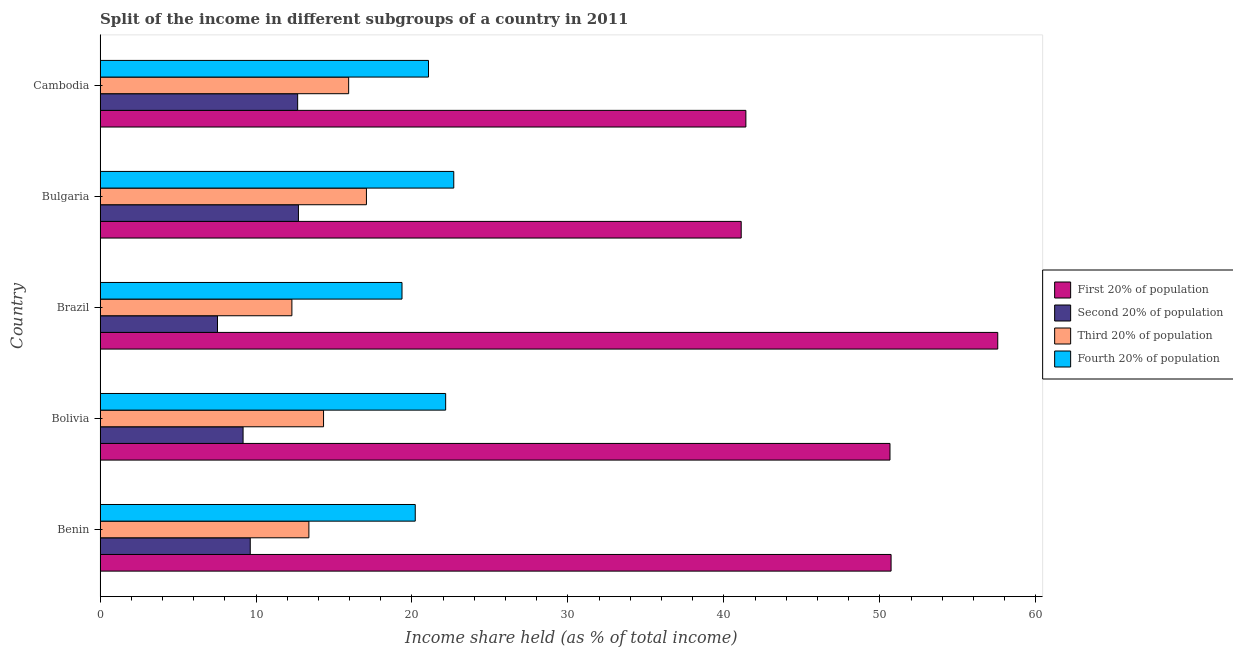Are the number of bars per tick equal to the number of legend labels?
Your response must be concise. Yes. Are the number of bars on each tick of the Y-axis equal?
Your answer should be very brief. Yes. How many bars are there on the 1st tick from the top?
Make the answer very short. 4. How many bars are there on the 4th tick from the bottom?
Offer a terse response. 4. What is the label of the 2nd group of bars from the top?
Your answer should be very brief. Bulgaria. What is the share of the income held by second 20% of the population in Bulgaria?
Provide a short and direct response. 12.72. Across all countries, what is the maximum share of the income held by third 20% of the population?
Provide a succinct answer. 17.08. Across all countries, what is the minimum share of the income held by second 20% of the population?
Provide a short and direct response. 7.53. In which country was the share of the income held by third 20% of the population maximum?
Offer a terse response. Bulgaria. What is the total share of the income held by fourth 20% of the population in the graph?
Give a very brief answer. 105.47. What is the difference between the share of the income held by fourth 20% of the population in Brazil and that in Bulgaria?
Your answer should be compact. -3.32. What is the difference between the share of the income held by third 20% of the population in Benin and the share of the income held by second 20% of the population in Cambodia?
Your answer should be very brief. 0.72. What is the average share of the income held by fourth 20% of the population per country?
Your answer should be compact. 21.09. What is the difference between the share of the income held by fourth 20% of the population and share of the income held by second 20% of the population in Brazil?
Provide a short and direct response. 11.83. In how many countries, is the share of the income held by first 20% of the population greater than 22 %?
Give a very brief answer. 5. What is the ratio of the share of the income held by first 20% of the population in Benin to that in Bulgaria?
Give a very brief answer. 1.23. What is the difference between the highest and the second highest share of the income held by first 20% of the population?
Your answer should be compact. 6.84. What is the difference between the highest and the lowest share of the income held by second 20% of the population?
Keep it short and to the point. 5.19. In how many countries, is the share of the income held by third 20% of the population greater than the average share of the income held by third 20% of the population taken over all countries?
Make the answer very short. 2. What does the 2nd bar from the top in Brazil represents?
Your answer should be very brief. Third 20% of population. What does the 1st bar from the bottom in Cambodia represents?
Keep it short and to the point. First 20% of population. Is it the case that in every country, the sum of the share of the income held by first 20% of the population and share of the income held by second 20% of the population is greater than the share of the income held by third 20% of the population?
Provide a succinct answer. Yes. How many bars are there?
Make the answer very short. 20. Are all the bars in the graph horizontal?
Your answer should be compact. Yes. Does the graph contain grids?
Your answer should be very brief. No. How are the legend labels stacked?
Offer a very short reply. Vertical. What is the title of the graph?
Ensure brevity in your answer.  Split of the income in different subgroups of a country in 2011. Does "Subsidies and Transfers" appear as one of the legend labels in the graph?
Offer a terse response. No. What is the label or title of the X-axis?
Your answer should be compact. Income share held (as % of total income). What is the label or title of the Y-axis?
Make the answer very short. Country. What is the Income share held (as % of total income) in First 20% of population in Benin?
Ensure brevity in your answer.  50.72. What is the Income share held (as % of total income) of Second 20% of population in Benin?
Make the answer very short. 9.63. What is the Income share held (as % of total income) in Third 20% of population in Benin?
Your response must be concise. 13.39. What is the Income share held (as % of total income) in Fourth 20% of population in Benin?
Your answer should be compact. 20.21. What is the Income share held (as % of total income) in First 20% of population in Bolivia?
Give a very brief answer. 50.65. What is the Income share held (as % of total income) of Second 20% of population in Bolivia?
Keep it short and to the point. 9.17. What is the Income share held (as % of total income) in Third 20% of population in Bolivia?
Your answer should be very brief. 14.33. What is the Income share held (as % of total income) in Fourth 20% of population in Bolivia?
Ensure brevity in your answer.  22.16. What is the Income share held (as % of total income) in First 20% of population in Brazil?
Give a very brief answer. 57.56. What is the Income share held (as % of total income) of Second 20% of population in Brazil?
Provide a succinct answer. 7.53. What is the Income share held (as % of total income) of Third 20% of population in Brazil?
Provide a succinct answer. 12.3. What is the Income share held (as % of total income) of Fourth 20% of population in Brazil?
Your response must be concise. 19.36. What is the Income share held (as % of total income) of First 20% of population in Bulgaria?
Offer a terse response. 41.11. What is the Income share held (as % of total income) of Second 20% of population in Bulgaria?
Your answer should be very brief. 12.72. What is the Income share held (as % of total income) of Third 20% of population in Bulgaria?
Offer a terse response. 17.08. What is the Income share held (as % of total income) of Fourth 20% of population in Bulgaria?
Keep it short and to the point. 22.68. What is the Income share held (as % of total income) in First 20% of population in Cambodia?
Give a very brief answer. 41.41. What is the Income share held (as % of total income) of Second 20% of population in Cambodia?
Your answer should be very brief. 12.67. What is the Income share held (as % of total income) of Third 20% of population in Cambodia?
Your answer should be very brief. 15.94. What is the Income share held (as % of total income) in Fourth 20% of population in Cambodia?
Your response must be concise. 21.06. Across all countries, what is the maximum Income share held (as % of total income) in First 20% of population?
Offer a very short reply. 57.56. Across all countries, what is the maximum Income share held (as % of total income) of Second 20% of population?
Provide a short and direct response. 12.72. Across all countries, what is the maximum Income share held (as % of total income) in Third 20% of population?
Your answer should be very brief. 17.08. Across all countries, what is the maximum Income share held (as % of total income) in Fourth 20% of population?
Offer a very short reply. 22.68. Across all countries, what is the minimum Income share held (as % of total income) of First 20% of population?
Make the answer very short. 41.11. Across all countries, what is the minimum Income share held (as % of total income) in Second 20% of population?
Your answer should be compact. 7.53. Across all countries, what is the minimum Income share held (as % of total income) in Fourth 20% of population?
Give a very brief answer. 19.36. What is the total Income share held (as % of total income) in First 20% of population in the graph?
Ensure brevity in your answer.  241.45. What is the total Income share held (as % of total income) of Second 20% of population in the graph?
Ensure brevity in your answer.  51.72. What is the total Income share held (as % of total income) of Third 20% of population in the graph?
Your answer should be very brief. 73.04. What is the total Income share held (as % of total income) of Fourth 20% of population in the graph?
Make the answer very short. 105.47. What is the difference between the Income share held (as % of total income) of First 20% of population in Benin and that in Bolivia?
Your answer should be very brief. 0.07. What is the difference between the Income share held (as % of total income) of Second 20% of population in Benin and that in Bolivia?
Ensure brevity in your answer.  0.46. What is the difference between the Income share held (as % of total income) of Third 20% of population in Benin and that in Bolivia?
Offer a very short reply. -0.94. What is the difference between the Income share held (as % of total income) of Fourth 20% of population in Benin and that in Bolivia?
Offer a terse response. -1.95. What is the difference between the Income share held (as % of total income) in First 20% of population in Benin and that in Brazil?
Your answer should be very brief. -6.84. What is the difference between the Income share held (as % of total income) in Third 20% of population in Benin and that in Brazil?
Ensure brevity in your answer.  1.09. What is the difference between the Income share held (as % of total income) in Fourth 20% of population in Benin and that in Brazil?
Keep it short and to the point. 0.85. What is the difference between the Income share held (as % of total income) in First 20% of population in Benin and that in Bulgaria?
Offer a terse response. 9.61. What is the difference between the Income share held (as % of total income) in Second 20% of population in Benin and that in Bulgaria?
Offer a very short reply. -3.09. What is the difference between the Income share held (as % of total income) in Third 20% of population in Benin and that in Bulgaria?
Offer a terse response. -3.69. What is the difference between the Income share held (as % of total income) of Fourth 20% of population in Benin and that in Bulgaria?
Offer a very short reply. -2.47. What is the difference between the Income share held (as % of total income) in First 20% of population in Benin and that in Cambodia?
Your answer should be very brief. 9.31. What is the difference between the Income share held (as % of total income) in Second 20% of population in Benin and that in Cambodia?
Provide a short and direct response. -3.04. What is the difference between the Income share held (as % of total income) of Third 20% of population in Benin and that in Cambodia?
Offer a very short reply. -2.55. What is the difference between the Income share held (as % of total income) of Fourth 20% of population in Benin and that in Cambodia?
Offer a terse response. -0.85. What is the difference between the Income share held (as % of total income) of First 20% of population in Bolivia and that in Brazil?
Your response must be concise. -6.91. What is the difference between the Income share held (as % of total income) of Second 20% of population in Bolivia and that in Brazil?
Your answer should be very brief. 1.64. What is the difference between the Income share held (as % of total income) in Third 20% of population in Bolivia and that in Brazil?
Offer a terse response. 2.03. What is the difference between the Income share held (as % of total income) of Fourth 20% of population in Bolivia and that in Brazil?
Offer a very short reply. 2.8. What is the difference between the Income share held (as % of total income) of First 20% of population in Bolivia and that in Bulgaria?
Your response must be concise. 9.54. What is the difference between the Income share held (as % of total income) in Second 20% of population in Bolivia and that in Bulgaria?
Provide a short and direct response. -3.55. What is the difference between the Income share held (as % of total income) of Third 20% of population in Bolivia and that in Bulgaria?
Provide a short and direct response. -2.75. What is the difference between the Income share held (as % of total income) of Fourth 20% of population in Bolivia and that in Bulgaria?
Give a very brief answer. -0.52. What is the difference between the Income share held (as % of total income) in First 20% of population in Bolivia and that in Cambodia?
Provide a succinct answer. 9.24. What is the difference between the Income share held (as % of total income) of Second 20% of population in Bolivia and that in Cambodia?
Your response must be concise. -3.5. What is the difference between the Income share held (as % of total income) of Third 20% of population in Bolivia and that in Cambodia?
Offer a very short reply. -1.61. What is the difference between the Income share held (as % of total income) in Fourth 20% of population in Bolivia and that in Cambodia?
Give a very brief answer. 1.1. What is the difference between the Income share held (as % of total income) of First 20% of population in Brazil and that in Bulgaria?
Your response must be concise. 16.45. What is the difference between the Income share held (as % of total income) of Second 20% of population in Brazil and that in Bulgaria?
Offer a very short reply. -5.19. What is the difference between the Income share held (as % of total income) of Third 20% of population in Brazil and that in Bulgaria?
Your answer should be compact. -4.78. What is the difference between the Income share held (as % of total income) in Fourth 20% of population in Brazil and that in Bulgaria?
Make the answer very short. -3.32. What is the difference between the Income share held (as % of total income) of First 20% of population in Brazil and that in Cambodia?
Keep it short and to the point. 16.15. What is the difference between the Income share held (as % of total income) of Second 20% of population in Brazil and that in Cambodia?
Give a very brief answer. -5.14. What is the difference between the Income share held (as % of total income) of Third 20% of population in Brazil and that in Cambodia?
Give a very brief answer. -3.64. What is the difference between the Income share held (as % of total income) in Fourth 20% of population in Brazil and that in Cambodia?
Give a very brief answer. -1.7. What is the difference between the Income share held (as % of total income) of First 20% of population in Bulgaria and that in Cambodia?
Provide a short and direct response. -0.3. What is the difference between the Income share held (as % of total income) in Third 20% of population in Bulgaria and that in Cambodia?
Your response must be concise. 1.14. What is the difference between the Income share held (as % of total income) of Fourth 20% of population in Bulgaria and that in Cambodia?
Ensure brevity in your answer.  1.62. What is the difference between the Income share held (as % of total income) in First 20% of population in Benin and the Income share held (as % of total income) in Second 20% of population in Bolivia?
Offer a terse response. 41.55. What is the difference between the Income share held (as % of total income) of First 20% of population in Benin and the Income share held (as % of total income) of Third 20% of population in Bolivia?
Ensure brevity in your answer.  36.39. What is the difference between the Income share held (as % of total income) of First 20% of population in Benin and the Income share held (as % of total income) of Fourth 20% of population in Bolivia?
Your answer should be very brief. 28.56. What is the difference between the Income share held (as % of total income) of Second 20% of population in Benin and the Income share held (as % of total income) of Fourth 20% of population in Bolivia?
Ensure brevity in your answer.  -12.53. What is the difference between the Income share held (as % of total income) in Third 20% of population in Benin and the Income share held (as % of total income) in Fourth 20% of population in Bolivia?
Provide a short and direct response. -8.77. What is the difference between the Income share held (as % of total income) of First 20% of population in Benin and the Income share held (as % of total income) of Second 20% of population in Brazil?
Offer a terse response. 43.19. What is the difference between the Income share held (as % of total income) of First 20% of population in Benin and the Income share held (as % of total income) of Third 20% of population in Brazil?
Keep it short and to the point. 38.42. What is the difference between the Income share held (as % of total income) of First 20% of population in Benin and the Income share held (as % of total income) of Fourth 20% of population in Brazil?
Offer a terse response. 31.36. What is the difference between the Income share held (as % of total income) of Second 20% of population in Benin and the Income share held (as % of total income) of Third 20% of population in Brazil?
Your answer should be compact. -2.67. What is the difference between the Income share held (as % of total income) in Second 20% of population in Benin and the Income share held (as % of total income) in Fourth 20% of population in Brazil?
Your answer should be very brief. -9.73. What is the difference between the Income share held (as % of total income) in Third 20% of population in Benin and the Income share held (as % of total income) in Fourth 20% of population in Brazil?
Offer a very short reply. -5.97. What is the difference between the Income share held (as % of total income) of First 20% of population in Benin and the Income share held (as % of total income) of Second 20% of population in Bulgaria?
Provide a succinct answer. 38. What is the difference between the Income share held (as % of total income) in First 20% of population in Benin and the Income share held (as % of total income) in Third 20% of population in Bulgaria?
Make the answer very short. 33.64. What is the difference between the Income share held (as % of total income) of First 20% of population in Benin and the Income share held (as % of total income) of Fourth 20% of population in Bulgaria?
Keep it short and to the point. 28.04. What is the difference between the Income share held (as % of total income) of Second 20% of population in Benin and the Income share held (as % of total income) of Third 20% of population in Bulgaria?
Ensure brevity in your answer.  -7.45. What is the difference between the Income share held (as % of total income) in Second 20% of population in Benin and the Income share held (as % of total income) in Fourth 20% of population in Bulgaria?
Offer a terse response. -13.05. What is the difference between the Income share held (as % of total income) of Third 20% of population in Benin and the Income share held (as % of total income) of Fourth 20% of population in Bulgaria?
Provide a short and direct response. -9.29. What is the difference between the Income share held (as % of total income) of First 20% of population in Benin and the Income share held (as % of total income) of Second 20% of population in Cambodia?
Keep it short and to the point. 38.05. What is the difference between the Income share held (as % of total income) in First 20% of population in Benin and the Income share held (as % of total income) in Third 20% of population in Cambodia?
Provide a short and direct response. 34.78. What is the difference between the Income share held (as % of total income) in First 20% of population in Benin and the Income share held (as % of total income) in Fourth 20% of population in Cambodia?
Ensure brevity in your answer.  29.66. What is the difference between the Income share held (as % of total income) of Second 20% of population in Benin and the Income share held (as % of total income) of Third 20% of population in Cambodia?
Ensure brevity in your answer.  -6.31. What is the difference between the Income share held (as % of total income) of Second 20% of population in Benin and the Income share held (as % of total income) of Fourth 20% of population in Cambodia?
Your response must be concise. -11.43. What is the difference between the Income share held (as % of total income) of Third 20% of population in Benin and the Income share held (as % of total income) of Fourth 20% of population in Cambodia?
Offer a very short reply. -7.67. What is the difference between the Income share held (as % of total income) in First 20% of population in Bolivia and the Income share held (as % of total income) in Second 20% of population in Brazil?
Provide a short and direct response. 43.12. What is the difference between the Income share held (as % of total income) of First 20% of population in Bolivia and the Income share held (as % of total income) of Third 20% of population in Brazil?
Give a very brief answer. 38.35. What is the difference between the Income share held (as % of total income) in First 20% of population in Bolivia and the Income share held (as % of total income) in Fourth 20% of population in Brazil?
Keep it short and to the point. 31.29. What is the difference between the Income share held (as % of total income) of Second 20% of population in Bolivia and the Income share held (as % of total income) of Third 20% of population in Brazil?
Ensure brevity in your answer.  -3.13. What is the difference between the Income share held (as % of total income) of Second 20% of population in Bolivia and the Income share held (as % of total income) of Fourth 20% of population in Brazil?
Your answer should be very brief. -10.19. What is the difference between the Income share held (as % of total income) in Third 20% of population in Bolivia and the Income share held (as % of total income) in Fourth 20% of population in Brazil?
Your answer should be very brief. -5.03. What is the difference between the Income share held (as % of total income) of First 20% of population in Bolivia and the Income share held (as % of total income) of Second 20% of population in Bulgaria?
Give a very brief answer. 37.93. What is the difference between the Income share held (as % of total income) of First 20% of population in Bolivia and the Income share held (as % of total income) of Third 20% of population in Bulgaria?
Offer a terse response. 33.57. What is the difference between the Income share held (as % of total income) of First 20% of population in Bolivia and the Income share held (as % of total income) of Fourth 20% of population in Bulgaria?
Ensure brevity in your answer.  27.97. What is the difference between the Income share held (as % of total income) in Second 20% of population in Bolivia and the Income share held (as % of total income) in Third 20% of population in Bulgaria?
Your answer should be very brief. -7.91. What is the difference between the Income share held (as % of total income) in Second 20% of population in Bolivia and the Income share held (as % of total income) in Fourth 20% of population in Bulgaria?
Your response must be concise. -13.51. What is the difference between the Income share held (as % of total income) of Third 20% of population in Bolivia and the Income share held (as % of total income) of Fourth 20% of population in Bulgaria?
Make the answer very short. -8.35. What is the difference between the Income share held (as % of total income) in First 20% of population in Bolivia and the Income share held (as % of total income) in Second 20% of population in Cambodia?
Your answer should be very brief. 37.98. What is the difference between the Income share held (as % of total income) of First 20% of population in Bolivia and the Income share held (as % of total income) of Third 20% of population in Cambodia?
Your answer should be very brief. 34.71. What is the difference between the Income share held (as % of total income) of First 20% of population in Bolivia and the Income share held (as % of total income) of Fourth 20% of population in Cambodia?
Offer a very short reply. 29.59. What is the difference between the Income share held (as % of total income) in Second 20% of population in Bolivia and the Income share held (as % of total income) in Third 20% of population in Cambodia?
Your answer should be compact. -6.77. What is the difference between the Income share held (as % of total income) of Second 20% of population in Bolivia and the Income share held (as % of total income) of Fourth 20% of population in Cambodia?
Provide a succinct answer. -11.89. What is the difference between the Income share held (as % of total income) in Third 20% of population in Bolivia and the Income share held (as % of total income) in Fourth 20% of population in Cambodia?
Provide a succinct answer. -6.73. What is the difference between the Income share held (as % of total income) in First 20% of population in Brazil and the Income share held (as % of total income) in Second 20% of population in Bulgaria?
Provide a short and direct response. 44.84. What is the difference between the Income share held (as % of total income) of First 20% of population in Brazil and the Income share held (as % of total income) of Third 20% of population in Bulgaria?
Give a very brief answer. 40.48. What is the difference between the Income share held (as % of total income) in First 20% of population in Brazil and the Income share held (as % of total income) in Fourth 20% of population in Bulgaria?
Your answer should be very brief. 34.88. What is the difference between the Income share held (as % of total income) of Second 20% of population in Brazil and the Income share held (as % of total income) of Third 20% of population in Bulgaria?
Your answer should be very brief. -9.55. What is the difference between the Income share held (as % of total income) in Second 20% of population in Brazil and the Income share held (as % of total income) in Fourth 20% of population in Bulgaria?
Make the answer very short. -15.15. What is the difference between the Income share held (as % of total income) of Third 20% of population in Brazil and the Income share held (as % of total income) of Fourth 20% of population in Bulgaria?
Your answer should be compact. -10.38. What is the difference between the Income share held (as % of total income) of First 20% of population in Brazil and the Income share held (as % of total income) of Second 20% of population in Cambodia?
Make the answer very short. 44.89. What is the difference between the Income share held (as % of total income) in First 20% of population in Brazil and the Income share held (as % of total income) in Third 20% of population in Cambodia?
Your answer should be compact. 41.62. What is the difference between the Income share held (as % of total income) in First 20% of population in Brazil and the Income share held (as % of total income) in Fourth 20% of population in Cambodia?
Make the answer very short. 36.5. What is the difference between the Income share held (as % of total income) of Second 20% of population in Brazil and the Income share held (as % of total income) of Third 20% of population in Cambodia?
Provide a short and direct response. -8.41. What is the difference between the Income share held (as % of total income) in Second 20% of population in Brazil and the Income share held (as % of total income) in Fourth 20% of population in Cambodia?
Offer a very short reply. -13.53. What is the difference between the Income share held (as % of total income) of Third 20% of population in Brazil and the Income share held (as % of total income) of Fourth 20% of population in Cambodia?
Give a very brief answer. -8.76. What is the difference between the Income share held (as % of total income) of First 20% of population in Bulgaria and the Income share held (as % of total income) of Second 20% of population in Cambodia?
Provide a short and direct response. 28.44. What is the difference between the Income share held (as % of total income) in First 20% of population in Bulgaria and the Income share held (as % of total income) in Third 20% of population in Cambodia?
Keep it short and to the point. 25.17. What is the difference between the Income share held (as % of total income) of First 20% of population in Bulgaria and the Income share held (as % of total income) of Fourth 20% of population in Cambodia?
Your answer should be very brief. 20.05. What is the difference between the Income share held (as % of total income) in Second 20% of population in Bulgaria and the Income share held (as % of total income) in Third 20% of population in Cambodia?
Give a very brief answer. -3.22. What is the difference between the Income share held (as % of total income) of Second 20% of population in Bulgaria and the Income share held (as % of total income) of Fourth 20% of population in Cambodia?
Offer a terse response. -8.34. What is the difference between the Income share held (as % of total income) in Third 20% of population in Bulgaria and the Income share held (as % of total income) in Fourth 20% of population in Cambodia?
Your answer should be compact. -3.98. What is the average Income share held (as % of total income) of First 20% of population per country?
Your response must be concise. 48.29. What is the average Income share held (as % of total income) in Second 20% of population per country?
Provide a short and direct response. 10.34. What is the average Income share held (as % of total income) in Third 20% of population per country?
Your response must be concise. 14.61. What is the average Income share held (as % of total income) in Fourth 20% of population per country?
Your answer should be compact. 21.09. What is the difference between the Income share held (as % of total income) of First 20% of population and Income share held (as % of total income) of Second 20% of population in Benin?
Your answer should be very brief. 41.09. What is the difference between the Income share held (as % of total income) in First 20% of population and Income share held (as % of total income) in Third 20% of population in Benin?
Offer a very short reply. 37.33. What is the difference between the Income share held (as % of total income) of First 20% of population and Income share held (as % of total income) of Fourth 20% of population in Benin?
Your answer should be compact. 30.51. What is the difference between the Income share held (as % of total income) of Second 20% of population and Income share held (as % of total income) of Third 20% of population in Benin?
Ensure brevity in your answer.  -3.76. What is the difference between the Income share held (as % of total income) in Second 20% of population and Income share held (as % of total income) in Fourth 20% of population in Benin?
Provide a short and direct response. -10.58. What is the difference between the Income share held (as % of total income) of Third 20% of population and Income share held (as % of total income) of Fourth 20% of population in Benin?
Provide a short and direct response. -6.82. What is the difference between the Income share held (as % of total income) of First 20% of population and Income share held (as % of total income) of Second 20% of population in Bolivia?
Provide a short and direct response. 41.48. What is the difference between the Income share held (as % of total income) in First 20% of population and Income share held (as % of total income) in Third 20% of population in Bolivia?
Offer a very short reply. 36.32. What is the difference between the Income share held (as % of total income) of First 20% of population and Income share held (as % of total income) of Fourth 20% of population in Bolivia?
Give a very brief answer. 28.49. What is the difference between the Income share held (as % of total income) in Second 20% of population and Income share held (as % of total income) in Third 20% of population in Bolivia?
Your response must be concise. -5.16. What is the difference between the Income share held (as % of total income) in Second 20% of population and Income share held (as % of total income) in Fourth 20% of population in Bolivia?
Offer a terse response. -12.99. What is the difference between the Income share held (as % of total income) in Third 20% of population and Income share held (as % of total income) in Fourth 20% of population in Bolivia?
Your response must be concise. -7.83. What is the difference between the Income share held (as % of total income) in First 20% of population and Income share held (as % of total income) in Second 20% of population in Brazil?
Give a very brief answer. 50.03. What is the difference between the Income share held (as % of total income) of First 20% of population and Income share held (as % of total income) of Third 20% of population in Brazil?
Keep it short and to the point. 45.26. What is the difference between the Income share held (as % of total income) in First 20% of population and Income share held (as % of total income) in Fourth 20% of population in Brazil?
Your answer should be compact. 38.2. What is the difference between the Income share held (as % of total income) in Second 20% of population and Income share held (as % of total income) in Third 20% of population in Brazil?
Give a very brief answer. -4.77. What is the difference between the Income share held (as % of total income) in Second 20% of population and Income share held (as % of total income) in Fourth 20% of population in Brazil?
Your response must be concise. -11.83. What is the difference between the Income share held (as % of total income) of Third 20% of population and Income share held (as % of total income) of Fourth 20% of population in Brazil?
Provide a short and direct response. -7.06. What is the difference between the Income share held (as % of total income) in First 20% of population and Income share held (as % of total income) in Second 20% of population in Bulgaria?
Your answer should be compact. 28.39. What is the difference between the Income share held (as % of total income) of First 20% of population and Income share held (as % of total income) of Third 20% of population in Bulgaria?
Give a very brief answer. 24.03. What is the difference between the Income share held (as % of total income) in First 20% of population and Income share held (as % of total income) in Fourth 20% of population in Bulgaria?
Provide a succinct answer. 18.43. What is the difference between the Income share held (as % of total income) of Second 20% of population and Income share held (as % of total income) of Third 20% of population in Bulgaria?
Your response must be concise. -4.36. What is the difference between the Income share held (as % of total income) in Second 20% of population and Income share held (as % of total income) in Fourth 20% of population in Bulgaria?
Provide a short and direct response. -9.96. What is the difference between the Income share held (as % of total income) in First 20% of population and Income share held (as % of total income) in Second 20% of population in Cambodia?
Offer a very short reply. 28.74. What is the difference between the Income share held (as % of total income) in First 20% of population and Income share held (as % of total income) in Third 20% of population in Cambodia?
Offer a terse response. 25.47. What is the difference between the Income share held (as % of total income) in First 20% of population and Income share held (as % of total income) in Fourth 20% of population in Cambodia?
Offer a very short reply. 20.35. What is the difference between the Income share held (as % of total income) of Second 20% of population and Income share held (as % of total income) of Third 20% of population in Cambodia?
Keep it short and to the point. -3.27. What is the difference between the Income share held (as % of total income) in Second 20% of population and Income share held (as % of total income) in Fourth 20% of population in Cambodia?
Your response must be concise. -8.39. What is the difference between the Income share held (as % of total income) in Third 20% of population and Income share held (as % of total income) in Fourth 20% of population in Cambodia?
Keep it short and to the point. -5.12. What is the ratio of the Income share held (as % of total income) in Second 20% of population in Benin to that in Bolivia?
Your answer should be very brief. 1.05. What is the ratio of the Income share held (as % of total income) of Third 20% of population in Benin to that in Bolivia?
Provide a succinct answer. 0.93. What is the ratio of the Income share held (as % of total income) in Fourth 20% of population in Benin to that in Bolivia?
Give a very brief answer. 0.91. What is the ratio of the Income share held (as % of total income) in First 20% of population in Benin to that in Brazil?
Your response must be concise. 0.88. What is the ratio of the Income share held (as % of total income) of Second 20% of population in Benin to that in Brazil?
Make the answer very short. 1.28. What is the ratio of the Income share held (as % of total income) in Third 20% of population in Benin to that in Brazil?
Ensure brevity in your answer.  1.09. What is the ratio of the Income share held (as % of total income) of Fourth 20% of population in Benin to that in Brazil?
Ensure brevity in your answer.  1.04. What is the ratio of the Income share held (as % of total income) in First 20% of population in Benin to that in Bulgaria?
Your answer should be very brief. 1.23. What is the ratio of the Income share held (as % of total income) in Second 20% of population in Benin to that in Bulgaria?
Offer a very short reply. 0.76. What is the ratio of the Income share held (as % of total income) of Third 20% of population in Benin to that in Bulgaria?
Give a very brief answer. 0.78. What is the ratio of the Income share held (as % of total income) in Fourth 20% of population in Benin to that in Bulgaria?
Give a very brief answer. 0.89. What is the ratio of the Income share held (as % of total income) of First 20% of population in Benin to that in Cambodia?
Provide a succinct answer. 1.22. What is the ratio of the Income share held (as % of total income) in Second 20% of population in Benin to that in Cambodia?
Provide a short and direct response. 0.76. What is the ratio of the Income share held (as % of total income) of Third 20% of population in Benin to that in Cambodia?
Offer a terse response. 0.84. What is the ratio of the Income share held (as % of total income) in Fourth 20% of population in Benin to that in Cambodia?
Provide a succinct answer. 0.96. What is the ratio of the Income share held (as % of total income) in First 20% of population in Bolivia to that in Brazil?
Make the answer very short. 0.88. What is the ratio of the Income share held (as % of total income) of Second 20% of population in Bolivia to that in Brazil?
Offer a very short reply. 1.22. What is the ratio of the Income share held (as % of total income) in Third 20% of population in Bolivia to that in Brazil?
Make the answer very short. 1.17. What is the ratio of the Income share held (as % of total income) of Fourth 20% of population in Bolivia to that in Brazil?
Provide a short and direct response. 1.14. What is the ratio of the Income share held (as % of total income) of First 20% of population in Bolivia to that in Bulgaria?
Offer a very short reply. 1.23. What is the ratio of the Income share held (as % of total income) in Second 20% of population in Bolivia to that in Bulgaria?
Ensure brevity in your answer.  0.72. What is the ratio of the Income share held (as % of total income) of Third 20% of population in Bolivia to that in Bulgaria?
Provide a short and direct response. 0.84. What is the ratio of the Income share held (as % of total income) of Fourth 20% of population in Bolivia to that in Bulgaria?
Provide a short and direct response. 0.98. What is the ratio of the Income share held (as % of total income) in First 20% of population in Bolivia to that in Cambodia?
Provide a succinct answer. 1.22. What is the ratio of the Income share held (as % of total income) in Second 20% of population in Bolivia to that in Cambodia?
Give a very brief answer. 0.72. What is the ratio of the Income share held (as % of total income) in Third 20% of population in Bolivia to that in Cambodia?
Provide a short and direct response. 0.9. What is the ratio of the Income share held (as % of total income) in Fourth 20% of population in Bolivia to that in Cambodia?
Your answer should be compact. 1.05. What is the ratio of the Income share held (as % of total income) in First 20% of population in Brazil to that in Bulgaria?
Keep it short and to the point. 1.4. What is the ratio of the Income share held (as % of total income) of Second 20% of population in Brazil to that in Bulgaria?
Your response must be concise. 0.59. What is the ratio of the Income share held (as % of total income) of Third 20% of population in Brazil to that in Bulgaria?
Keep it short and to the point. 0.72. What is the ratio of the Income share held (as % of total income) in Fourth 20% of population in Brazil to that in Bulgaria?
Your response must be concise. 0.85. What is the ratio of the Income share held (as % of total income) of First 20% of population in Brazil to that in Cambodia?
Provide a succinct answer. 1.39. What is the ratio of the Income share held (as % of total income) of Second 20% of population in Brazil to that in Cambodia?
Provide a short and direct response. 0.59. What is the ratio of the Income share held (as % of total income) of Third 20% of population in Brazil to that in Cambodia?
Offer a very short reply. 0.77. What is the ratio of the Income share held (as % of total income) of Fourth 20% of population in Brazil to that in Cambodia?
Your answer should be compact. 0.92. What is the ratio of the Income share held (as % of total income) in First 20% of population in Bulgaria to that in Cambodia?
Ensure brevity in your answer.  0.99. What is the ratio of the Income share held (as % of total income) of Second 20% of population in Bulgaria to that in Cambodia?
Your answer should be compact. 1. What is the ratio of the Income share held (as % of total income) of Third 20% of population in Bulgaria to that in Cambodia?
Offer a very short reply. 1.07. What is the difference between the highest and the second highest Income share held (as % of total income) of First 20% of population?
Your answer should be compact. 6.84. What is the difference between the highest and the second highest Income share held (as % of total income) in Third 20% of population?
Provide a succinct answer. 1.14. What is the difference between the highest and the second highest Income share held (as % of total income) of Fourth 20% of population?
Provide a succinct answer. 0.52. What is the difference between the highest and the lowest Income share held (as % of total income) of First 20% of population?
Your answer should be compact. 16.45. What is the difference between the highest and the lowest Income share held (as % of total income) in Second 20% of population?
Provide a succinct answer. 5.19. What is the difference between the highest and the lowest Income share held (as % of total income) of Third 20% of population?
Give a very brief answer. 4.78. What is the difference between the highest and the lowest Income share held (as % of total income) of Fourth 20% of population?
Provide a succinct answer. 3.32. 